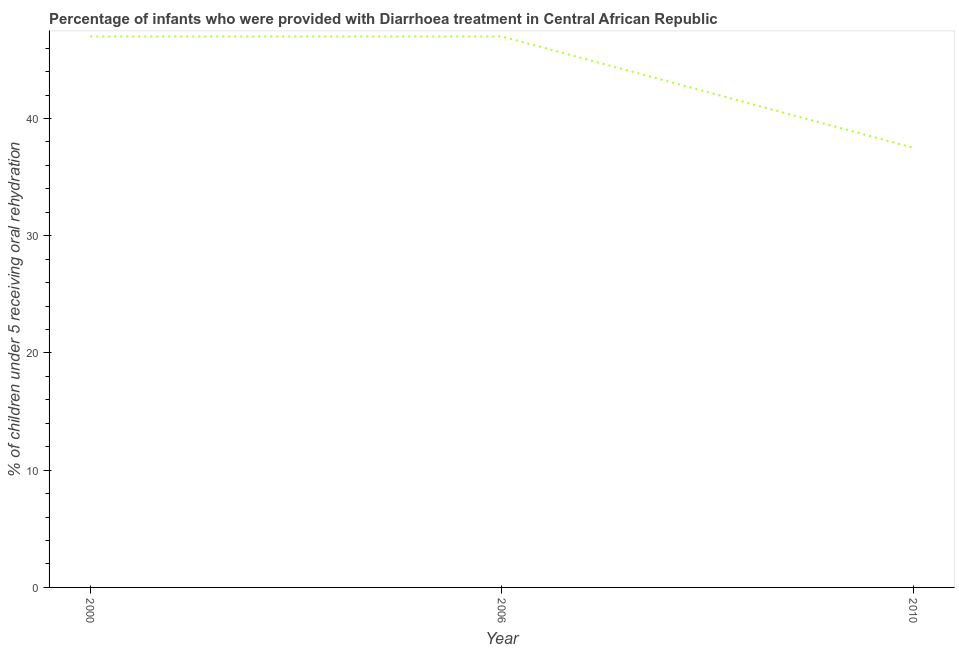What is the percentage of children who were provided with treatment diarrhoea in 2000?
Your response must be concise. 47. Across all years, what is the minimum percentage of children who were provided with treatment diarrhoea?
Offer a very short reply. 37.5. In which year was the percentage of children who were provided with treatment diarrhoea maximum?
Your response must be concise. 2000. In which year was the percentage of children who were provided with treatment diarrhoea minimum?
Give a very brief answer. 2010. What is the sum of the percentage of children who were provided with treatment diarrhoea?
Provide a short and direct response. 131.5. What is the difference between the percentage of children who were provided with treatment diarrhoea in 2006 and 2010?
Provide a succinct answer. 9.5. What is the average percentage of children who were provided with treatment diarrhoea per year?
Provide a short and direct response. 43.83. Do a majority of the years between 2010 and 2000 (inclusive) have percentage of children who were provided with treatment diarrhoea greater than 24 %?
Provide a succinct answer. No. What is the ratio of the percentage of children who were provided with treatment diarrhoea in 2006 to that in 2010?
Provide a succinct answer. 1.25. What is the difference between the highest and the second highest percentage of children who were provided with treatment diarrhoea?
Provide a short and direct response. 0. Is the sum of the percentage of children who were provided with treatment diarrhoea in 2000 and 2010 greater than the maximum percentage of children who were provided with treatment diarrhoea across all years?
Offer a very short reply. Yes. What is the difference between the highest and the lowest percentage of children who were provided with treatment diarrhoea?
Keep it short and to the point. 9.5. In how many years, is the percentage of children who were provided with treatment diarrhoea greater than the average percentage of children who were provided with treatment diarrhoea taken over all years?
Your answer should be very brief. 2. Does the percentage of children who were provided with treatment diarrhoea monotonically increase over the years?
Keep it short and to the point. No. How many years are there in the graph?
Make the answer very short. 3. What is the title of the graph?
Give a very brief answer. Percentage of infants who were provided with Diarrhoea treatment in Central African Republic. What is the label or title of the X-axis?
Keep it short and to the point. Year. What is the label or title of the Y-axis?
Your response must be concise. % of children under 5 receiving oral rehydration. What is the % of children under 5 receiving oral rehydration of 2000?
Ensure brevity in your answer.  47. What is the % of children under 5 receiving oral rehydration of 2010?
Ensure brevity in your answer.  37.5. What is the difference between the % of children under 5 receiving oral rehydration in 2000 and 2010?
Keep it short and to the point. 9.5. What is the difference between the % of children under 5 receiving oral rehydration in 2006 and 2010?
Make the answer very short. 9.5. What is the ratio of the % of children under 5 receiving oral rehydration in 2000 to that in 2010?
Provide a short and direct response. 1.25. What is the ratio of the % of children under 5 receiving oral rehydration in 2006 to that in 2010?
Offer a very short reply. 1.25. 